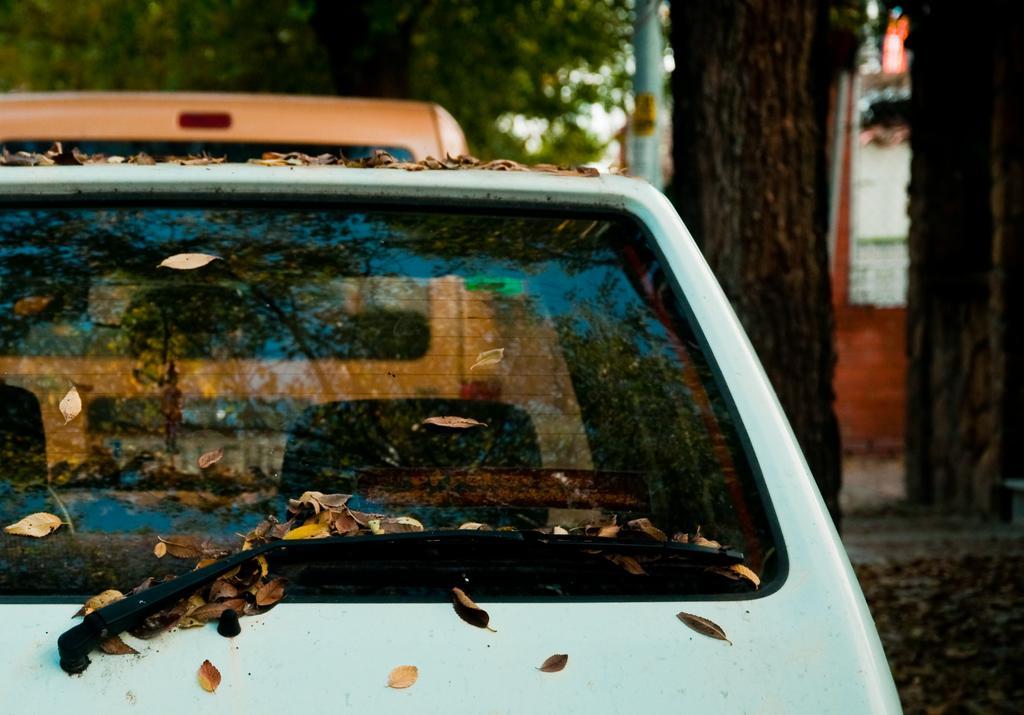Could you give a brief overview of what you see in this image? In this picture, we see vehicles in white and orange color are parked on the road. Beside that, we see the stem of the tree and a pole. In the background, there are trees and a building in white color. 